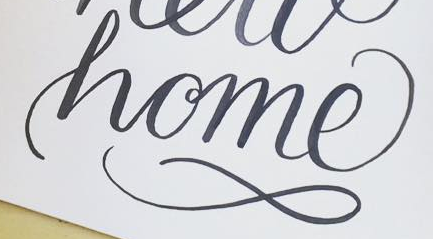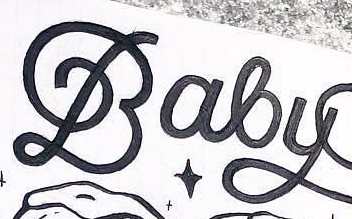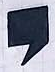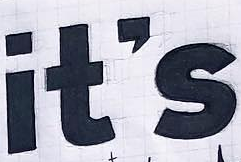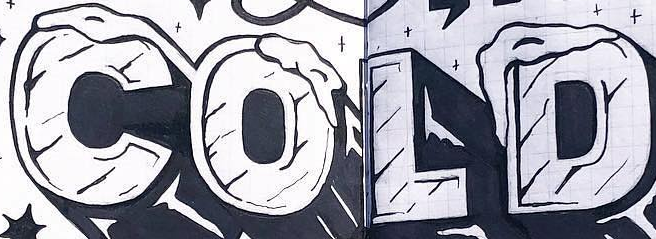Transcribe the words shown in these images in order, separated by a semicolon. home; Baby; ,; it's; COLD 